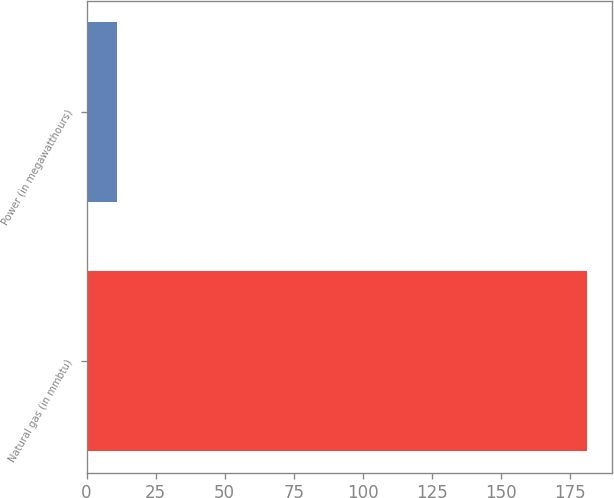Convert chart to OTSL. <chart><loc_0><loc_0><loc_500><loc_500><bar_chart><fcel>Natural gas (in mmbtu)<fcel>Power (in megawatthours)<nl><fcel>181<fcel>11<nl></chart> 